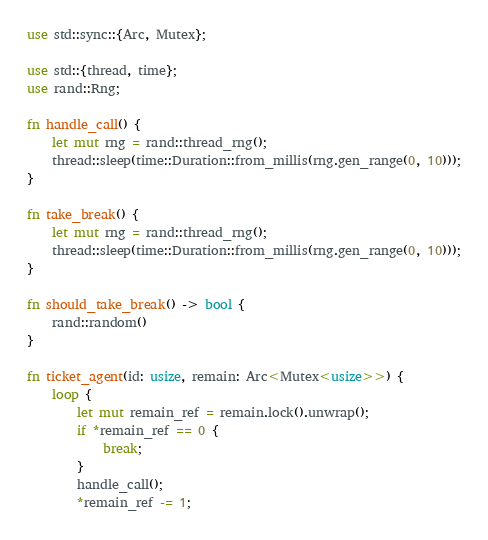<code> <loc_0><loc_0><loc_500><loc_500><_Rust_>use std::sync::{Arc, Mutex};

use std::{thread, time};
use rand::Rng;

fn handle_call() {
    let mut rng = rand::thread_rng();
    thread::sleep(time::Duration::from_millis(rng.gen_range(0, 10)));
}

fn take_break() {
    let mut rng = rand::thread_rng();
    thread::sleep(time::Duration::from_millis(rng.gen_range(0, 10)));
}

fn should_take_break() -> bool {
    rand::random()
}

fn ticket_agent(id: usize, remain: Arc<Mutex<usize>>) {
    loop {
        let mut remain_ref = remain.lock().unwrap();
        if *remain_ref == 0 {
            break;
        }
        handle_call();
        *remain_ref -= 1;</code> 